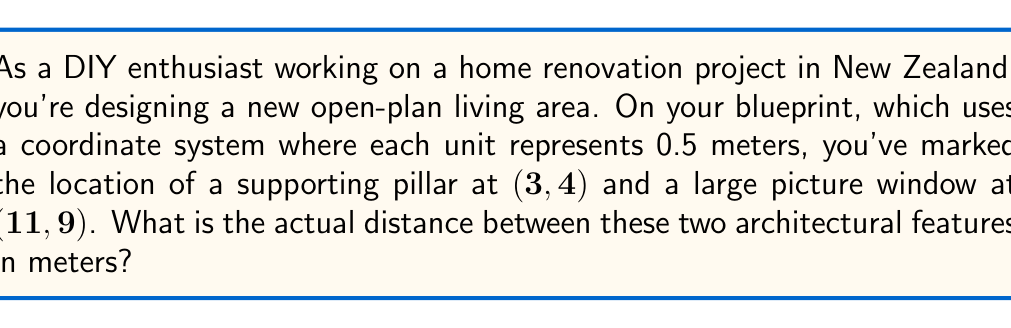Show me your answer to this math problem. To solve this problem, we'll follow these steps:

1) First, we need to calculate the distance between the two points on the coordinate system using the distance formula:

   $$d = \sqrt{(x_2 - x_1)^2 + (y_2 - y_1)^2}$$

   Where $(x_1, y_1)$ is the location of the pillar and $(x_2, y_2)$ is the location of the window.

2) Let's substitute our values:

   $$d = \sqrt{(11 - 3)^2 + (9 - 4)^2}$$

3) Simplify inside the parentheses:

   $$d = \sqrt{8^2 + 5^2}$$

4) Calculate the squares:

   $$d = \sqrt{64 + 25}$$

5) Add inside the square root:

   $$d = \sqrt{89}$$

6) This gives us the distance in coordinate units. However, we need to convert this to meters. Recall that each unit on the blueprint represents 0.5 meters. So we multiply our result by 0.5:

   $$\text{Distance in meters} = 0.5 \times \sqrt{89}$$

7) Simplify:

   $$\text{Distance in meters} = 0.5\sqrt{89} \approx 4.72 \text{ meters}$$

[asy]
unitsize(1cm);
draw((-1,-1)--(12,10), gray);
draw((-1,10)--(12,-1), gray);
for (int i=-1; i<=12; ++i) {
  draw((i,-0.2)--(i,0.2), gray);
  draw((-0.2,i)--(0.2,i), gray);
}
dot((3,4));
dot((11,9));
draw((3,4)--(11,9), red);
label("(3,4)", (3,4), SW);
label("(11,9)", (11,9), NE);
label("Pillar", (3,4), W);
label("Window", (11,9), E);
[/asy]
Answer: The actual distance between the supporting pillar and the picture window is approximately 4.72 meters. 